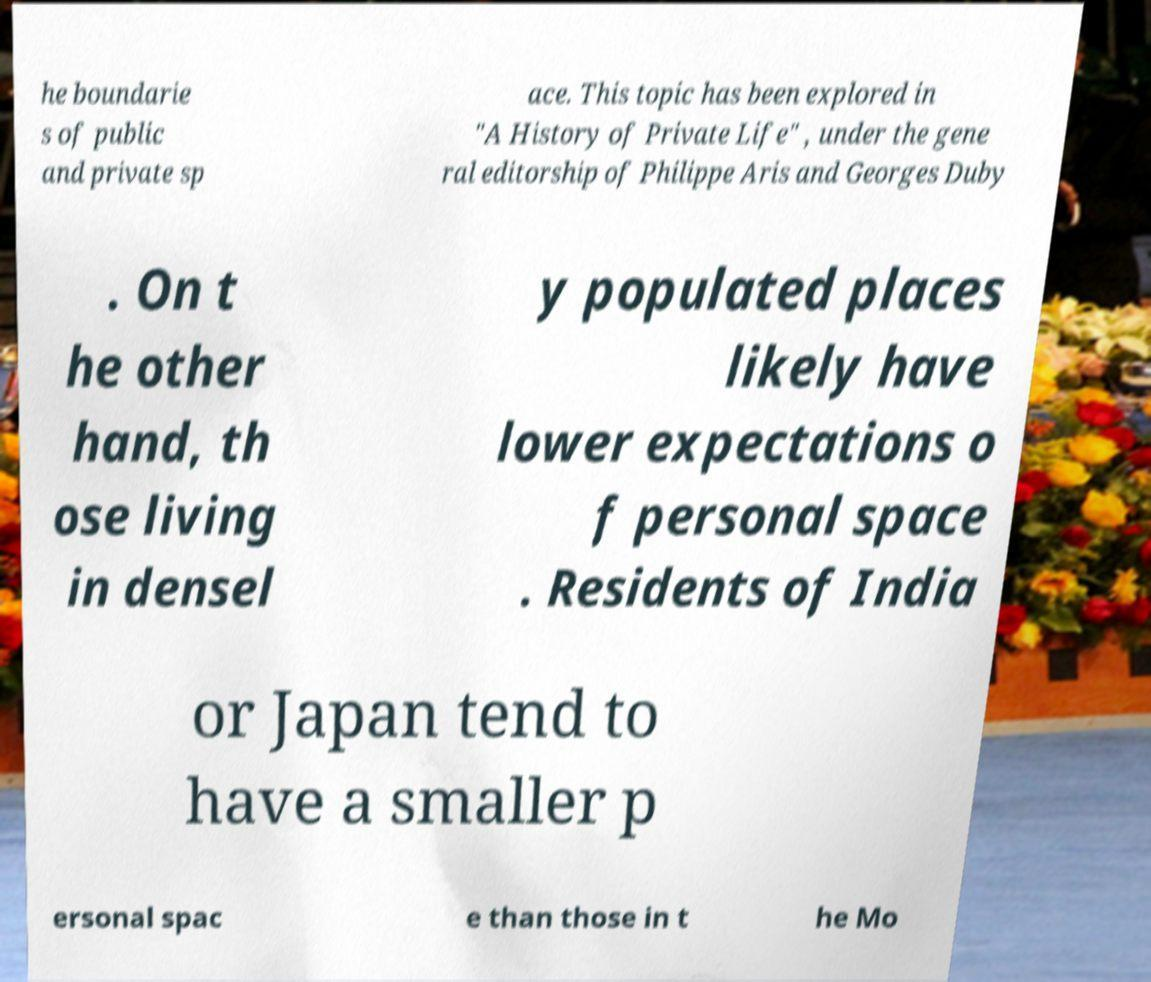Please read and relay the text visible in this image. What does it say? he boundarie s of public and private sp ace. This topic has been explored in "A History of Private Life" , under the gene ral editorship of Philippe Aris and Georges Duby . On t he other hand, th ose living in densel y populated places likely have lower expectations o f personal space . Residents of India or Japan tend to have a smaller p ersonal spac e than those in t he Mo 